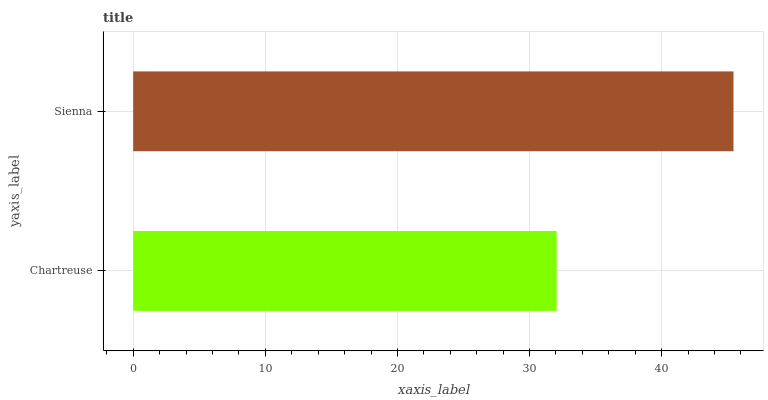Is Chartreuse the minimum?
Answer yes or no. Yes. Is Sienna the maximum?
Answer yes or no. Yes. Is Sienna the minimum?
Answer yes or no. No. Is Sienna greater than Chartreuse?
Answer yes or no. Yes. Is Chartreuse less than Sienna?
Answer yes or no. Yes. Is Chartreuse greater than Sienna?
Answer yes or no. No. Is Sienna less than Chartreuse?
Answer yes or no. No. Is Sienna the high median?
Answer yes or no. Yes. Is Chartreuse the low median?
Answer yes or no. Yes. Is Chartreuse the high median?
Answer yes or no. No. Is Sienna the low median?
Answer yes or no. No. 